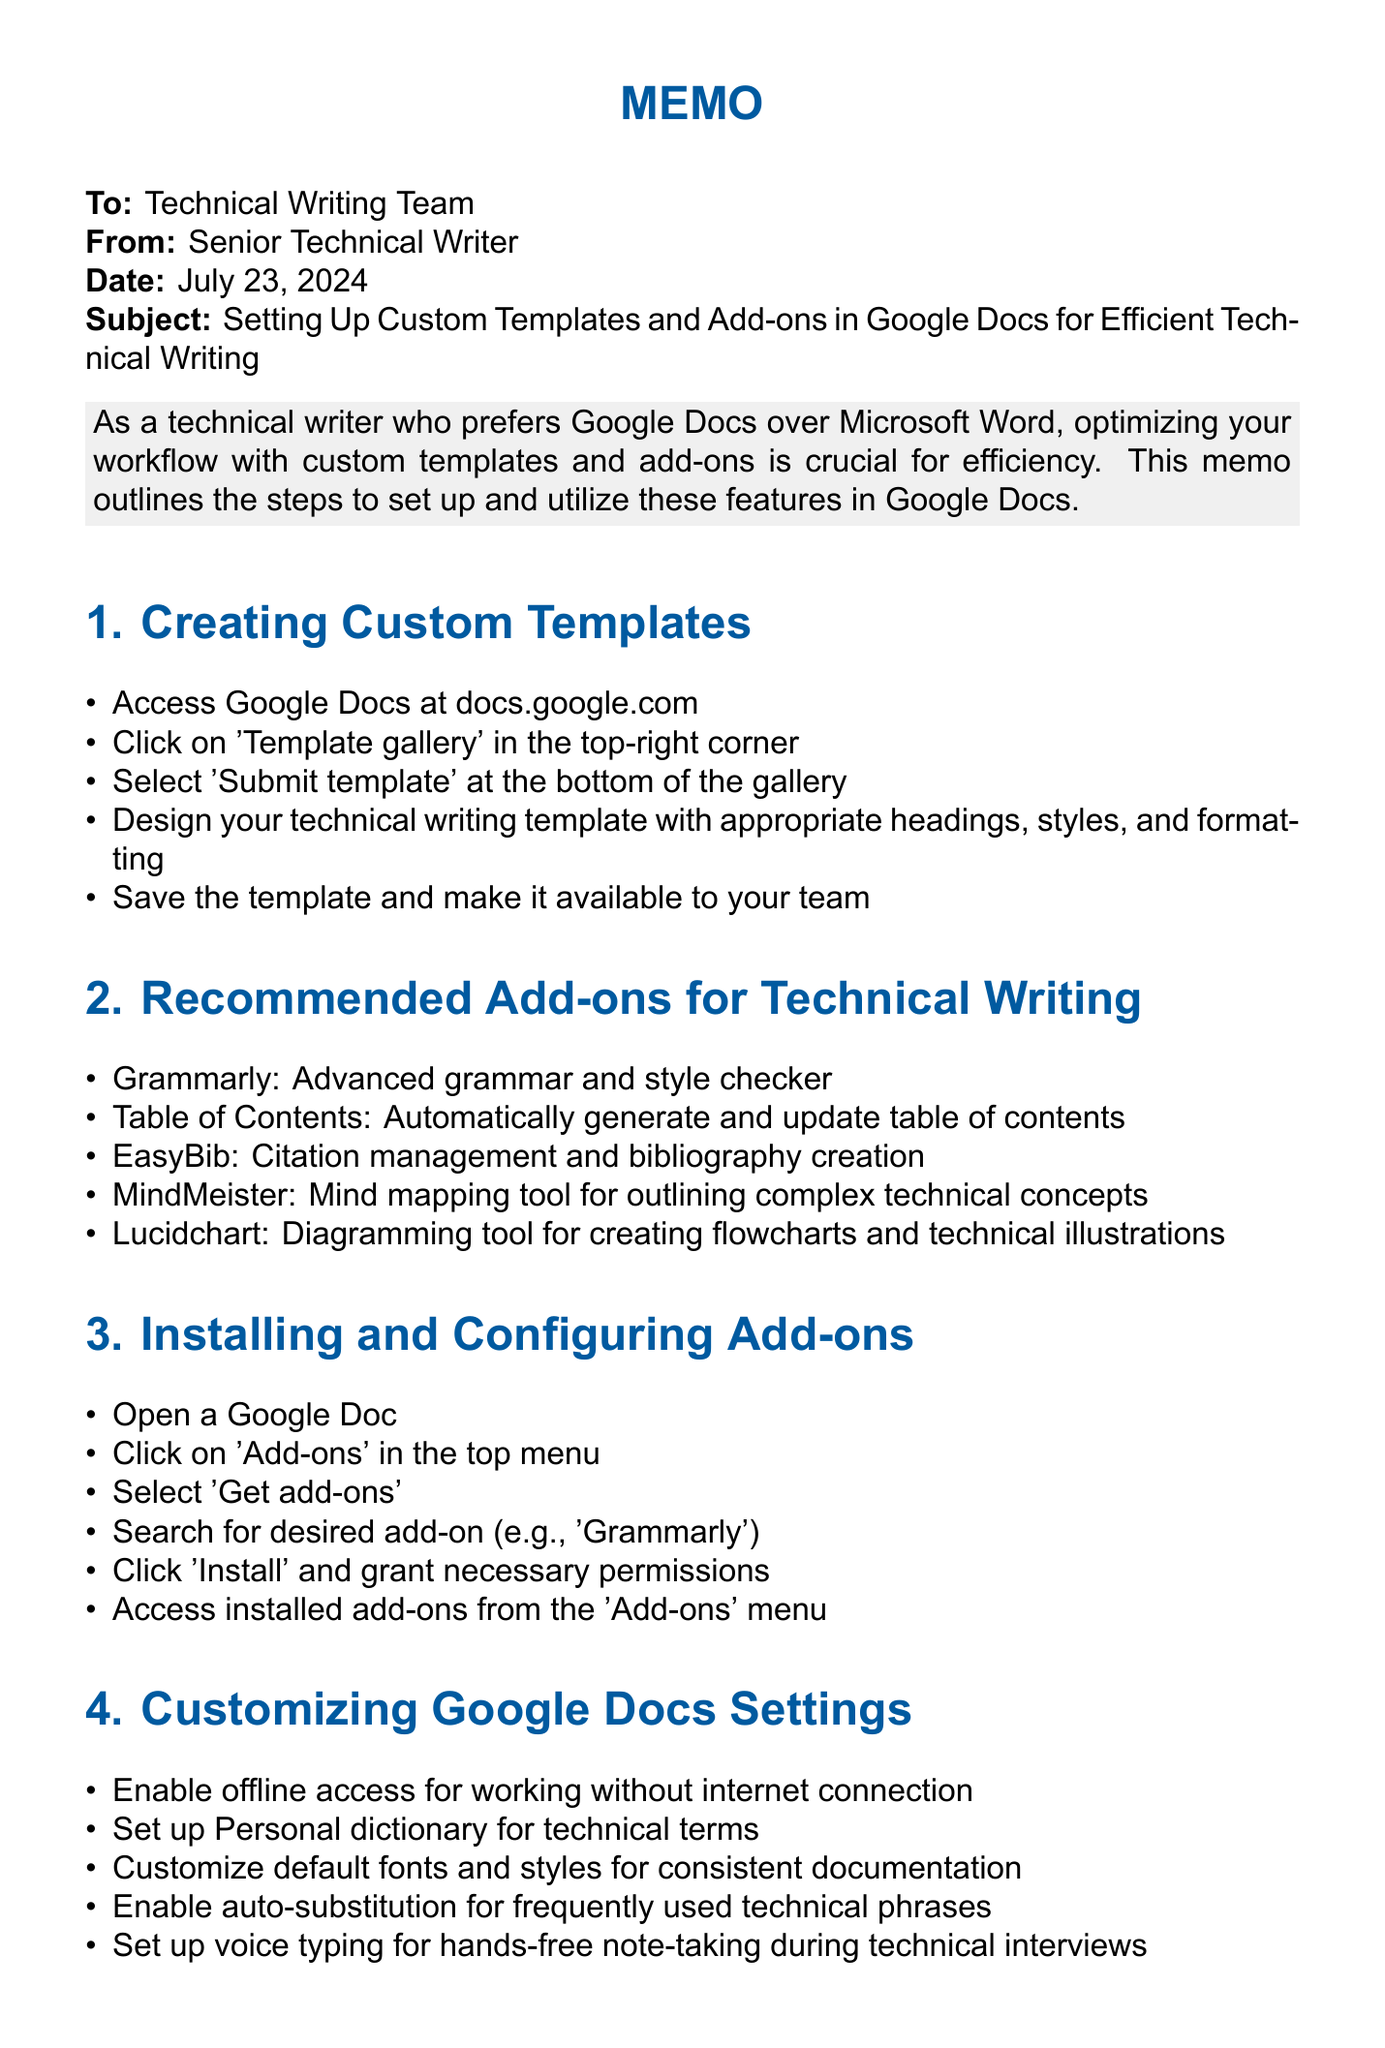What is the subject of the memo? The subject line of the memo provides the main topic being discussed, which is about custom templates and add-ons in Google Docs.
Answer: Setting Up Custom Templates and Add-ons in Google Docs for Efficient Technical Writing How many sections are in the memo? The memo contains several sections that outline specific topics regarding Google Docs, which can be counted.
Answer: 5 Which add-on is recommended for citation management? This item is found in the section that lists add-ons for technical writing, specifically mentioning its function.
Answer: EasyBib What mode should be used for peer reviews? The document specifies a mode designed for collaborative editing and suggestions.
Answer: Suggesting What should you enable for offline access? The memo suggests a setting that allows users to work without an internet connection.
Answer: Offline access Where can you access installed add-ons? The document mentions the menu option that provides access to add-ons once they are installed.
Answer: Add-ons menu What is one feature to customize for consistent documentation? The memo discusses customization options in Google Docs to maintain a uniform appearance across documents.
Answer: Default fonts and styles What tool is mentioned for mind mapping? The add-on listed for aiding in the organization and outlining of complex concepts is part of the recommended add-ons.
Answer: MindMeister 